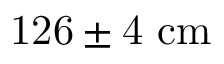<formula> <loc_0><loc_0><loc_500><loc_500>1 2 6 \pm 4 c m</formula> 